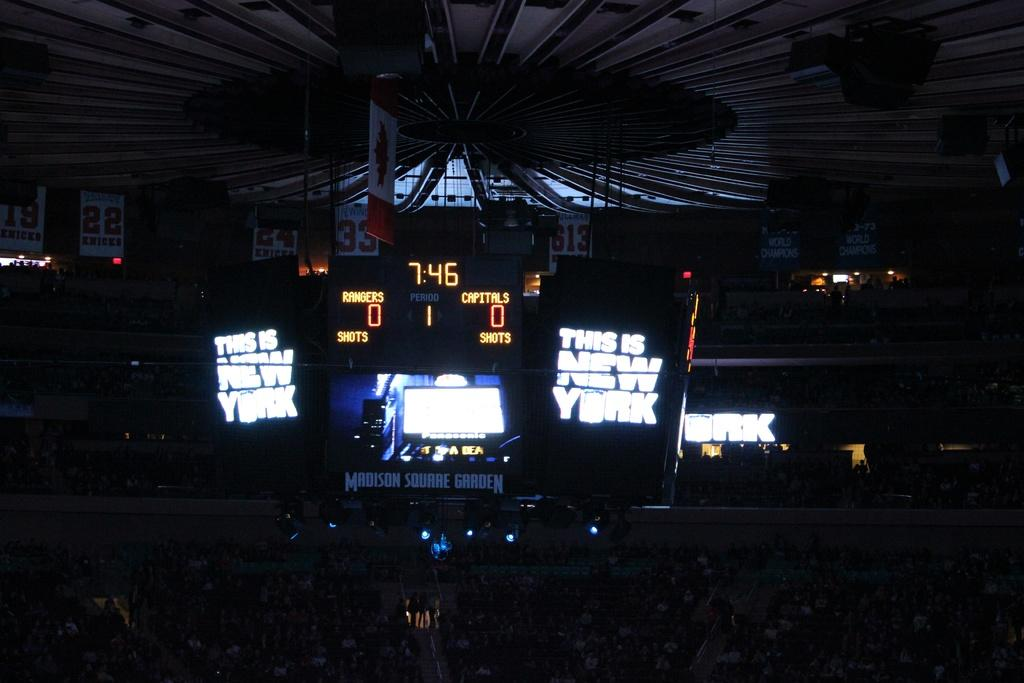Provide a one-sentence caption for the provided image. The score of the game is 0:0 at 7:46. 